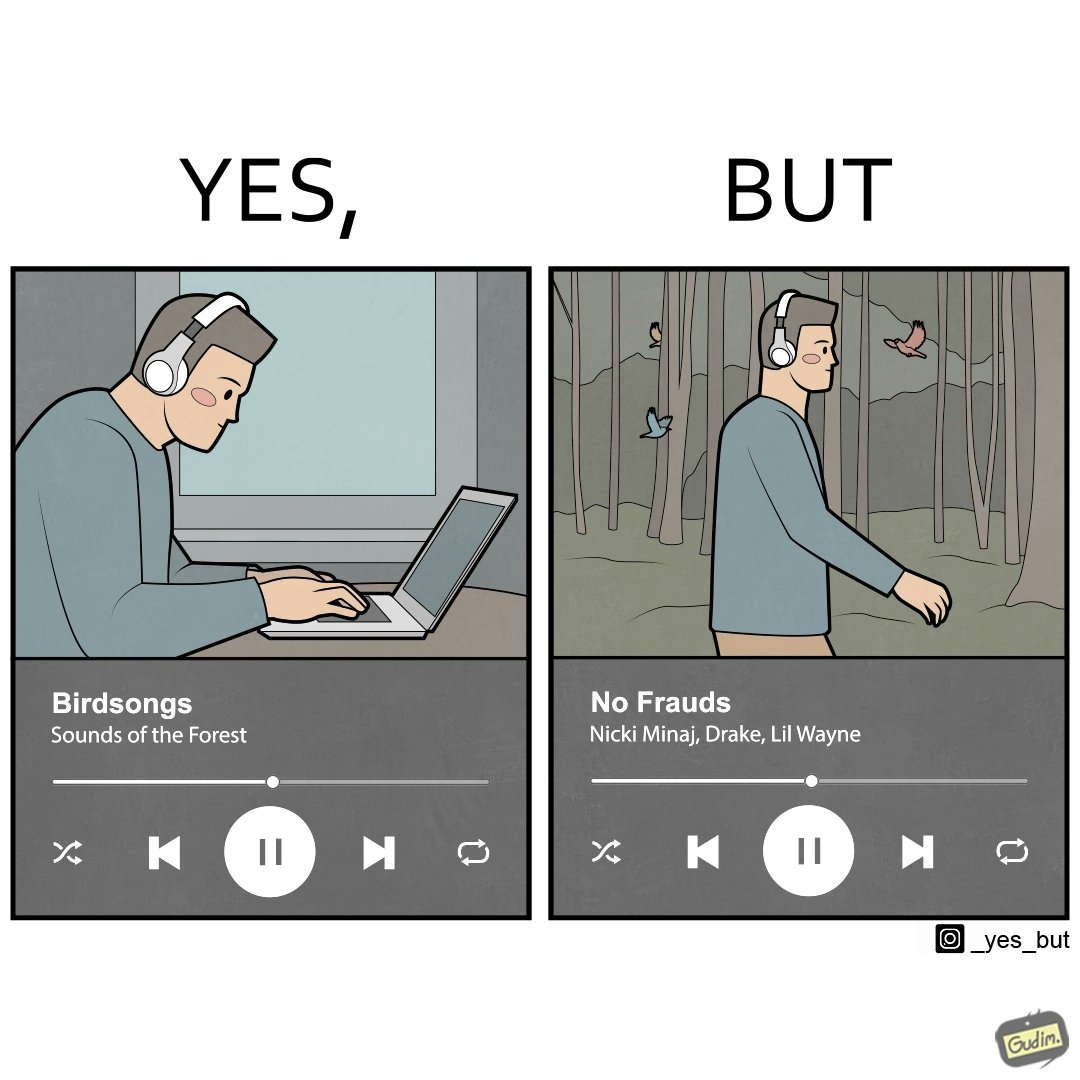Describe what you see in this image. The image is ironic, because people nowadays at home want to feel the nature but when the same person gets some moments to enjoy the nature they just ignore the surroundings 